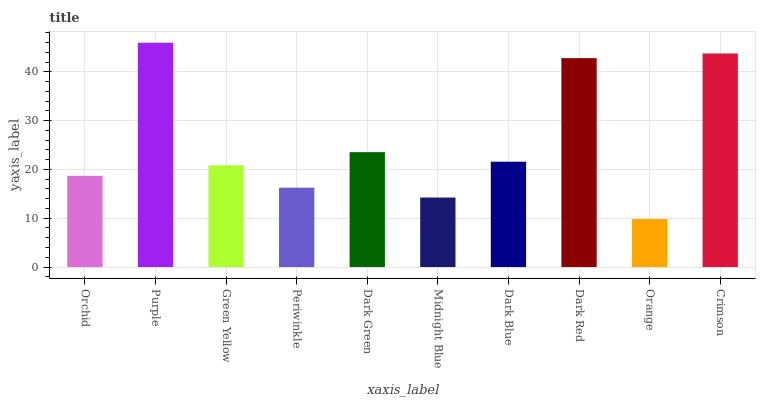Is Orange the minimum?
Answer yes or no. Yes. Is Purple the maximum?
Answer yes or no. Yes. Is Green Yellow the minimum?
Answer yes or no. No. Is Green Yellow the maximum?
Answer yes or no. No. Is Purple greater than Green Yellow?
Answer yes or no. Yes. Is Green Yellow less than Purple?
Answer yes or no. Yes. Is Green Yellow greater than Purple?
Answer yes or no. No. Is Purple less than Green Yellow?
Answer yes or no. No. Is Dark Blue the high median?
Answer yes or no. Yes. Is Green Yellow the low median?
Answer yes or no. Yes. Is Periwinkle the high median?
Answer yes or no. No. Is Midnight Blue the low median?
Answer yes or no. No. 